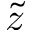<formula> <loc_0><loc_0><loc_500><loc_500>\tilde { z }</formula> 